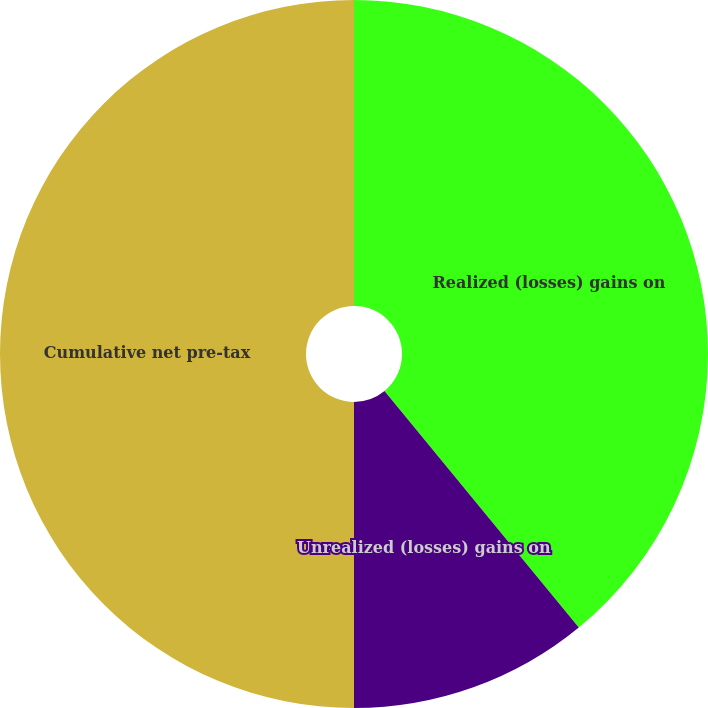Convert chart. <chart><loc_0><loc_0><loc_500><loc_500><pie_chart><fcel>Realized (losses) gains on<fcel>Unrealized (losses) gains on<fcel>Cumulative net pre-tax<nl><fcel>39.05%<fcel>10.95%<fcel>50.0%<nl></chart> 